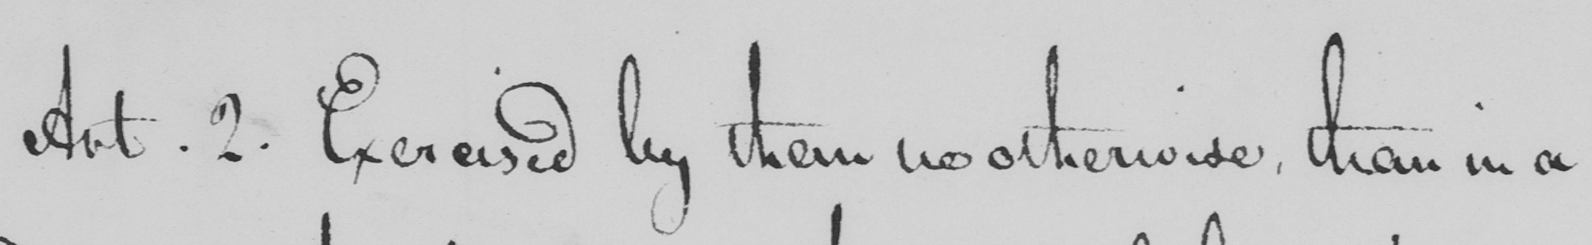Transcribe the text shown in this historical manuscript line. Art . 2 . Exercised by them no otherwise , than in a 